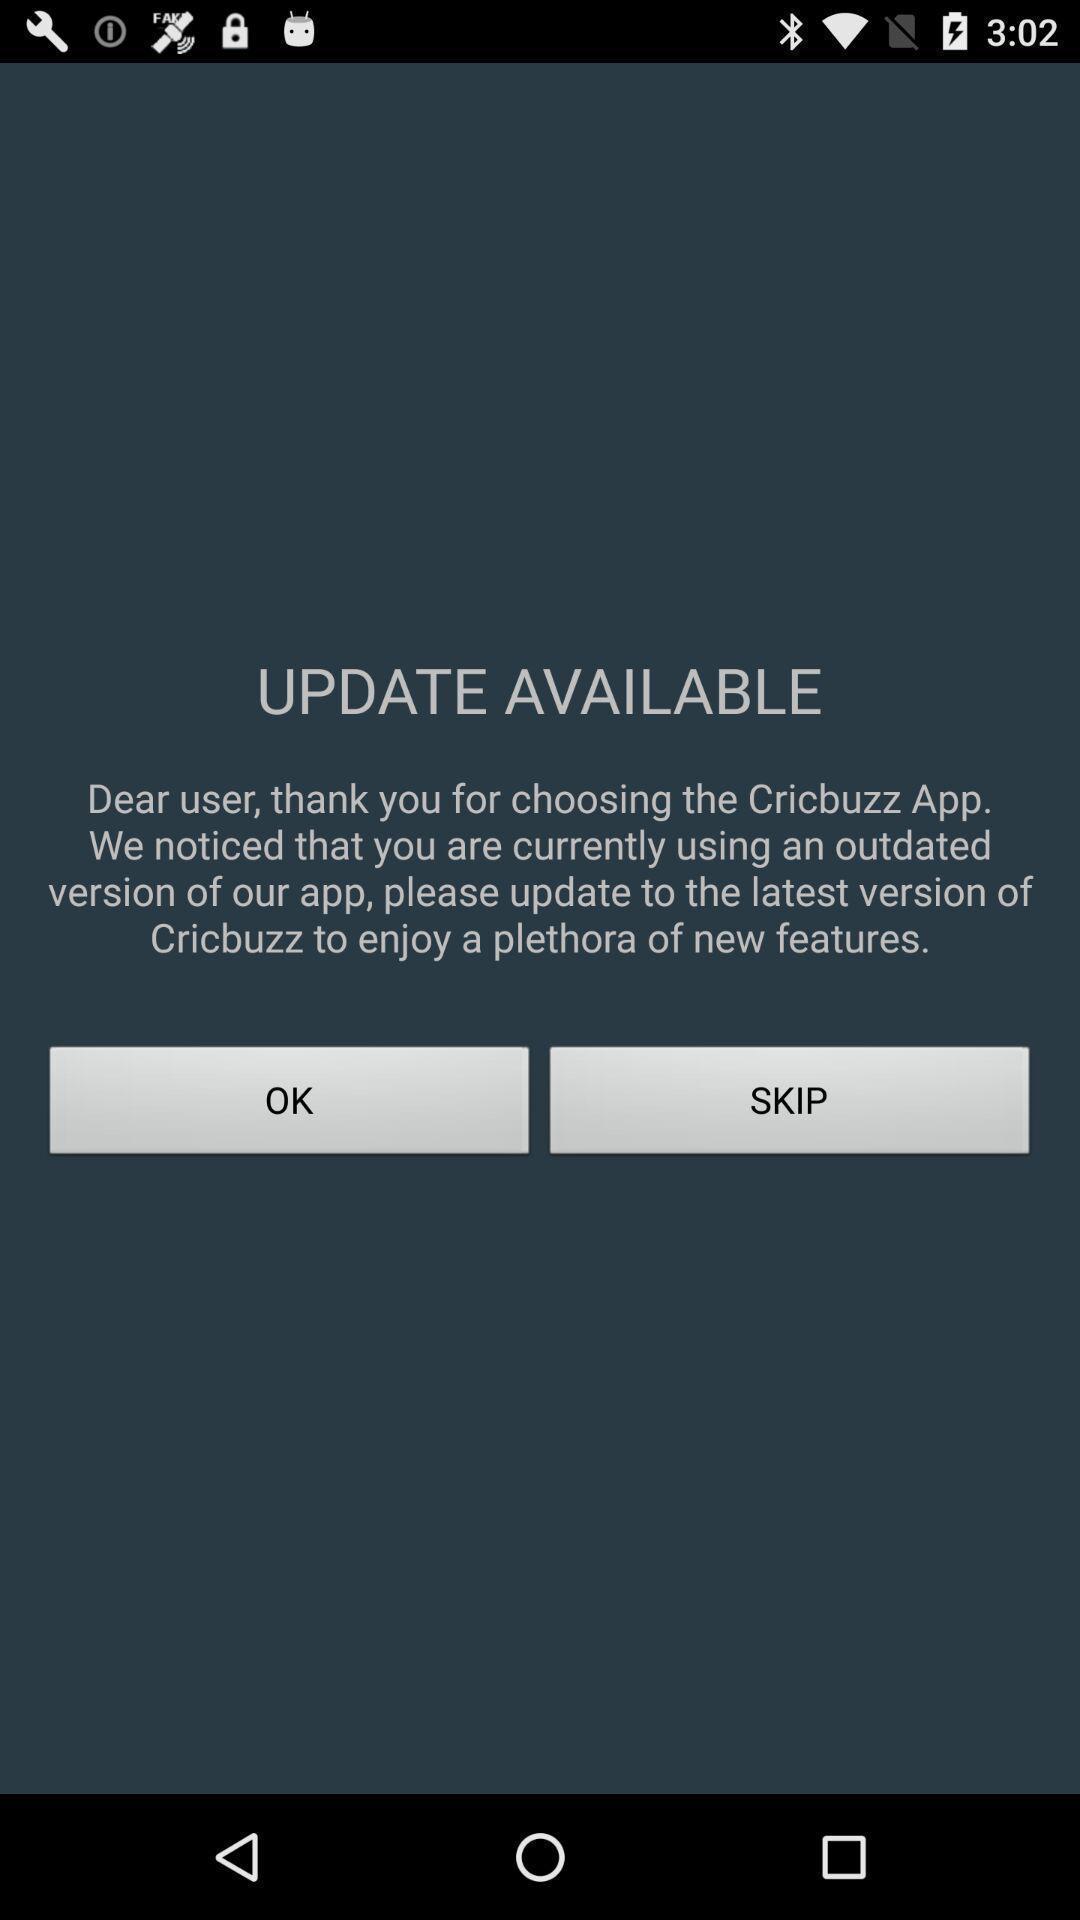Summarize the information in this screenshot. Window displaying an cricket app. 